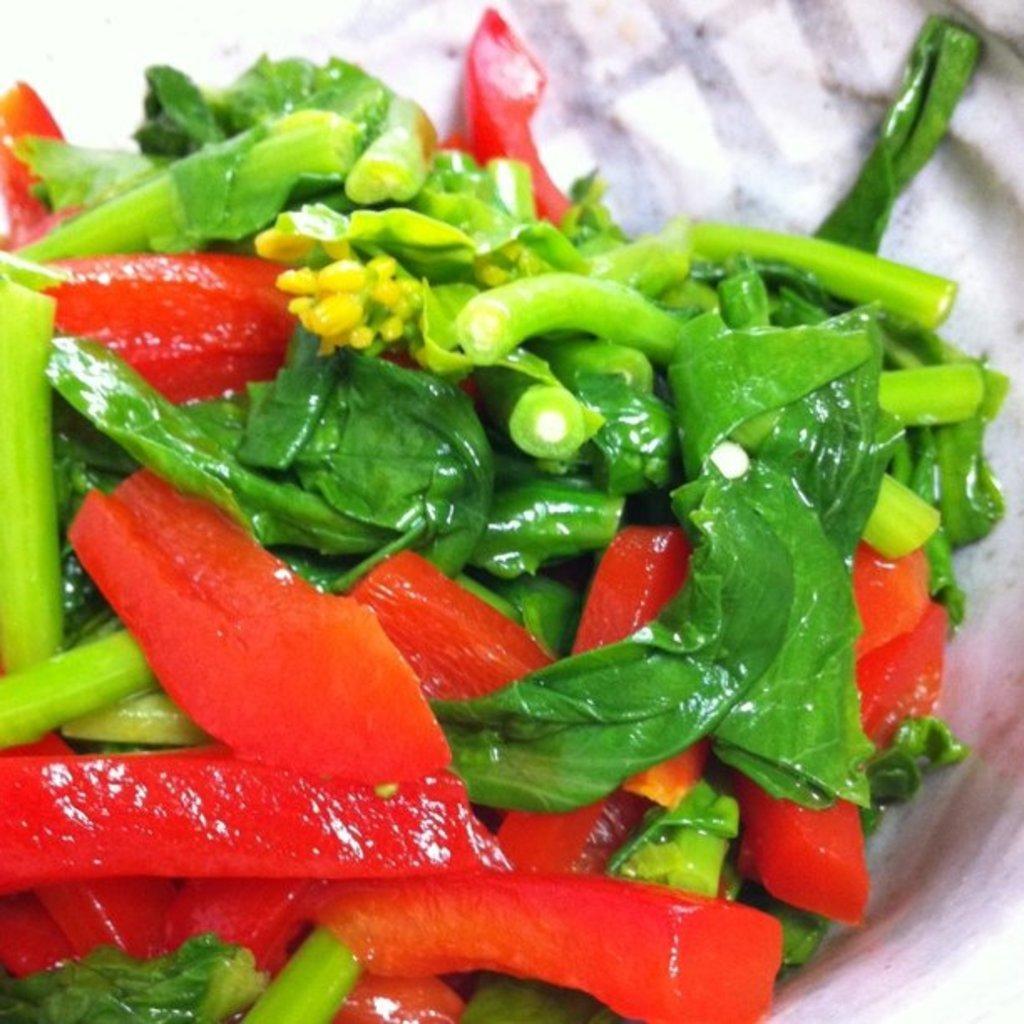Could you give a brief overview of what you see in this image? In this picture there is some salad, there are some green leafy vegetables and vegetables in the bowl. 